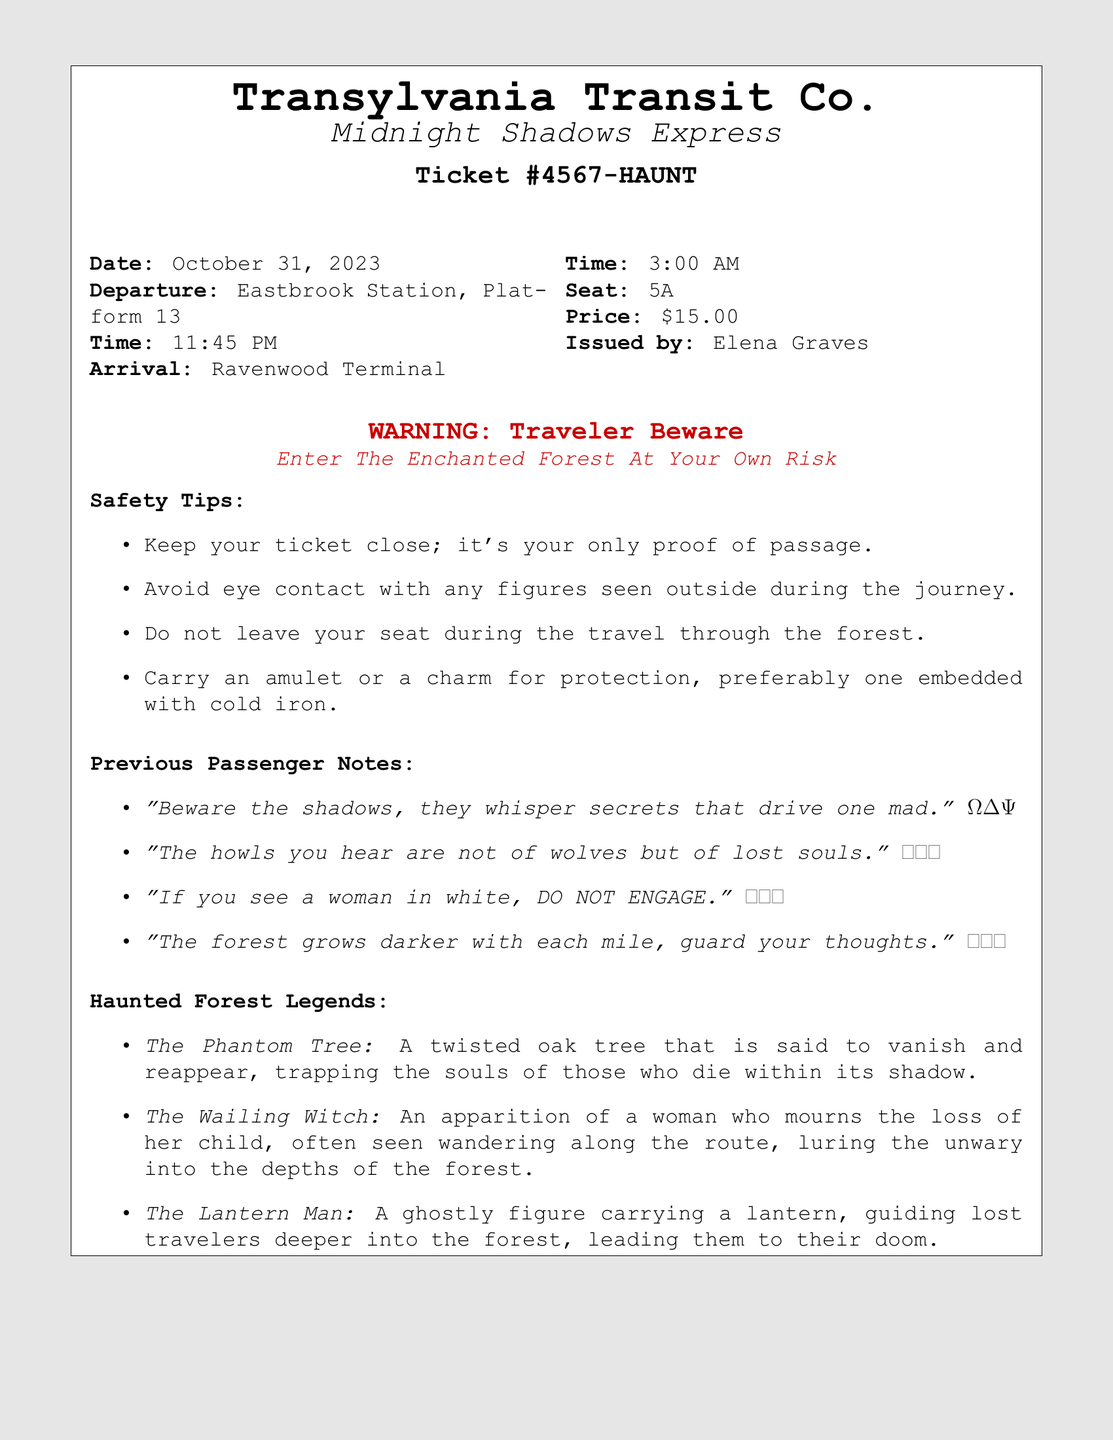What is the ticket number? The ticket number is specified on the ticket as Ticket #4567-HAUNT.
Answer: Ticket #4567-HAUNT What is the departure time? The document states the departure time is 11:45 PM.
Answer: 11:45 PM Who issued the ticket? The issuer's name is mentioned as Elena Graves in the document.
Answer: Elena Graves What is the seat number assigned? The seat number shown on the ticket is 5A.
Answer: 5A What is the price of the ticket? The price stated in the document for the ticket is $15.00.
Answer: $15.00 What should travelers avoid during the journey? A specified guideline is to avoid eye contact with any figures seen outside during the journey.
Answer: Eye contact with figures What is a safety tip mentioned in the document? The document outlines the safety tips, stating to keep the ticket close as it's the only proof of passage.
Answer: Keep your ticket close What kind of figure should not be engaged with? The notes advise that if a traveler sees a woman in white, they should not engage with her.
Answer: Woman in white What is the arrival time at Ravenwood Terminal? According to the document, the arrival time is stated as 3:00 AM.
Answer: 3:00 AM 